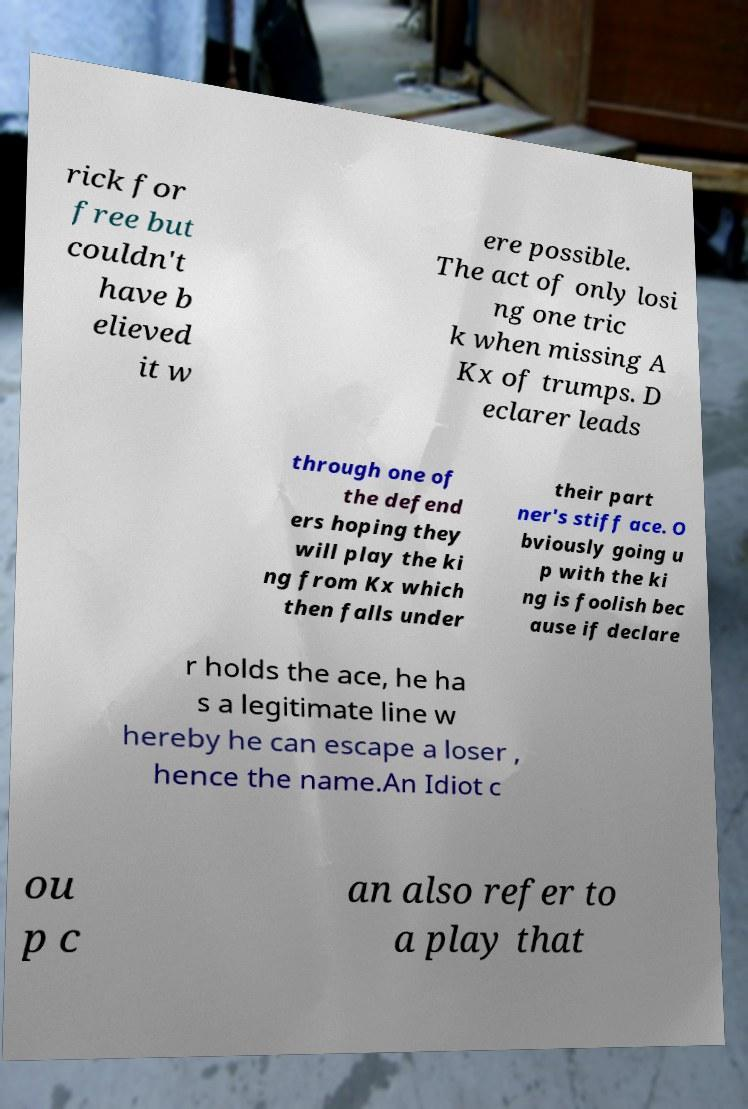Please read and relay the text visible in this image. What does it say? rick for free but couldn't have b elieved it w ere possible. The act of only losi ng one tric k when missing A Kx of trumps. D eclarer leads through one of the defend ers hoping they will play the ki ng from Kx which then falls under their part ner's stiff ace. O bviously going u p with the ki ng is foolish bec ause if declare r holds the ace, he ha s a legitimate line w hereby he can escape a loser , hence the name.An Idiot c ou p c an also refer to a play that 